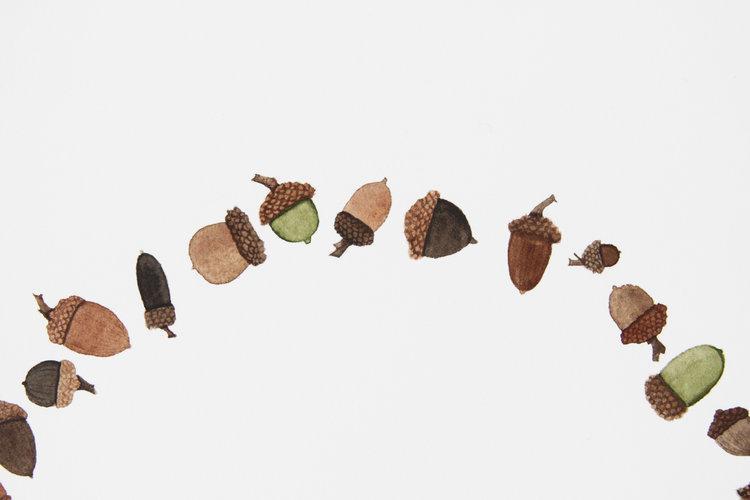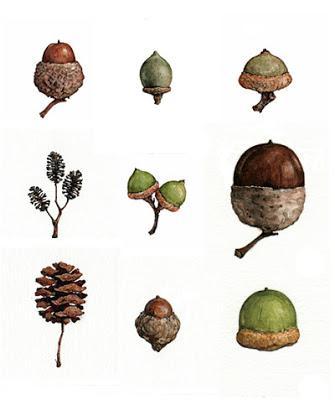The first image is the image on the left, the second image is the image on the right. Analyze the images presented: Is the assertion "There are exactly two acorns in the left image." valid? Answer yes or no. No. The first image is the image on the left, the second image is the image on the right. Analyze the images presented: Is the assertion "The left image includes two brown acorns, and at least one oak leaf on a stem above them." valid? Answer yes or no. No. 